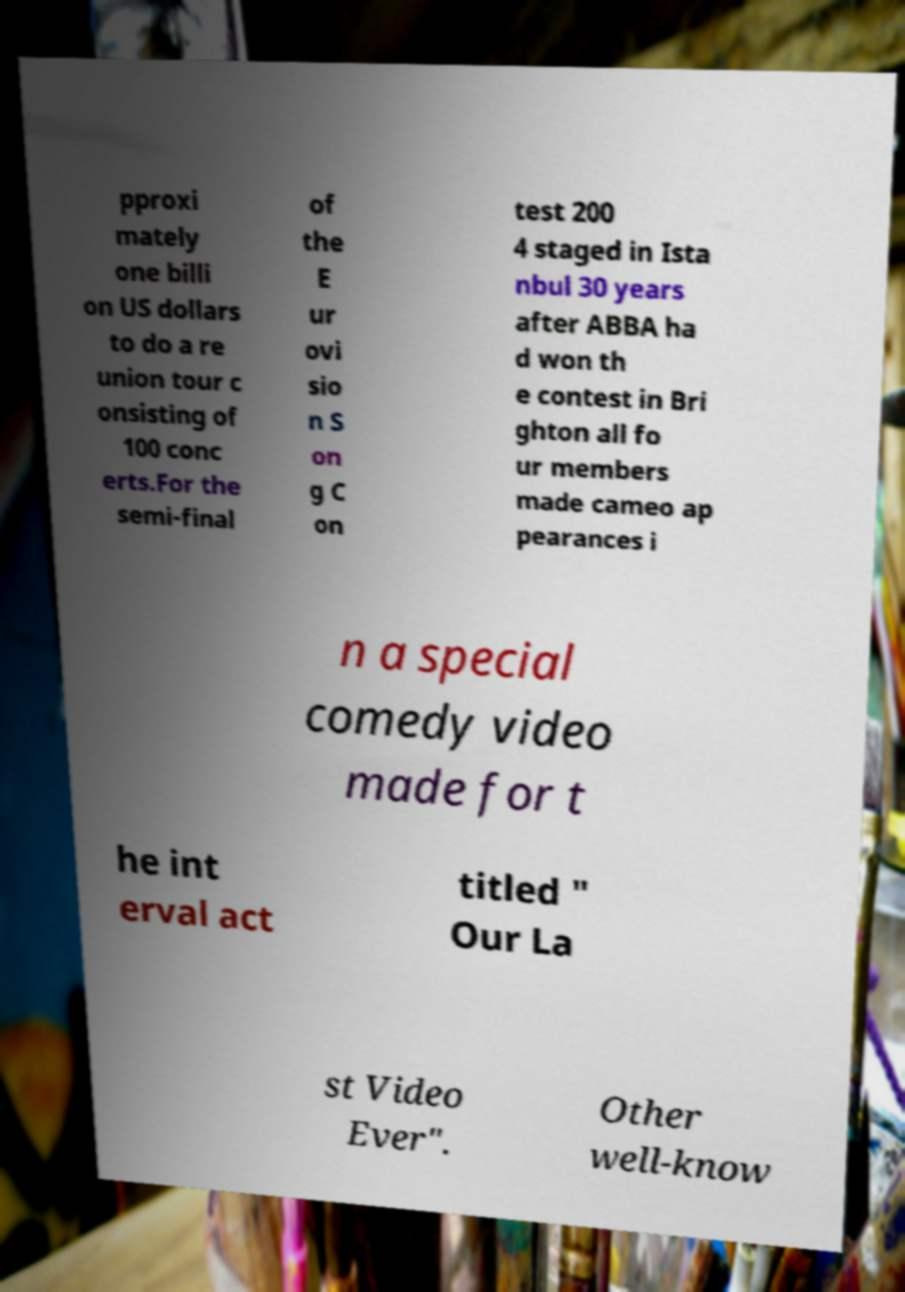There's text embedded in this image that I need extracted. Can you transcribe it verbatim? pproxi mately one billi on US dollars to do a re union tour c onsisting of 100 conc erts.For the semi-final of the E ur ovi sio n S on g C on test 200 4 staged in Ista nbul 30 years after ABBA ha d won th e contest in Bri ghton all fo ur members made cameo ap pearances i n a special comedy video made for t he int erval act titled " Our La st Video Ever". Other well-know 